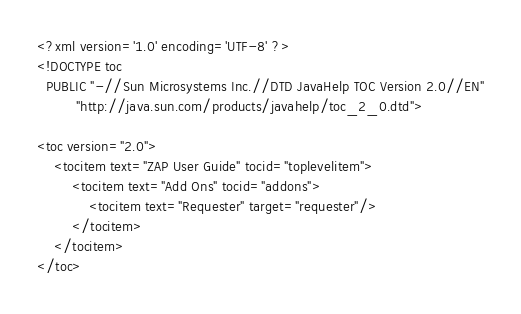Convert code to text. <code><loc_0><loc_0><loc_500><loc_500><_XML_><?xml version='1.0' encoding='UTF-8' ?>
<!DOCTYPE toc
  PUBLIC "-//Sun Microsystems Inc.//DTD JavaHelp TOC Version 2.0//EN"
         "http://java.sun.com/products/javahelp/toc_2_0.dtd">

<toc version="2.0">
    <tocitem text="ZAP User Guide" tocid="toplevelitem">
        <tocitem text="Add Ons" tocid="addons">
            <tocitem text="Requester" target="requester"/>
        </tocitem>
    </tocitem>
</toc>
</code> 